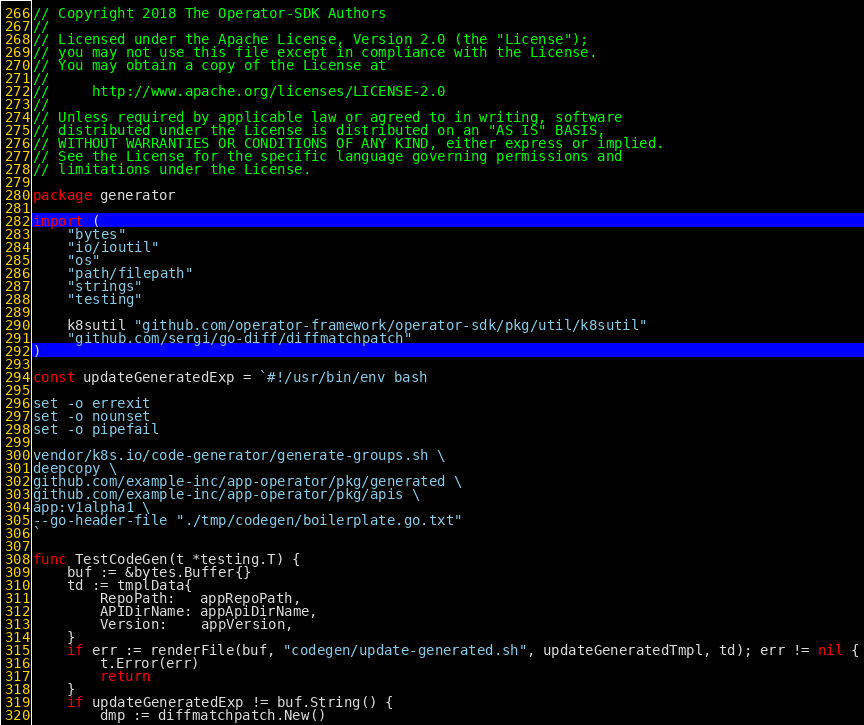<code> <loc_0><loc_0><loc_500><loc_500><_Go_>// Copyright 2018 The Operator-SDK Authors
//
// Licensed under the Apache License, Version 2.0 (the "License");
// you may not use this file except in compliance with the License.
// You may obtain a copy of the License at
//
//     http://www.apache.org/licenses/LICENSE-2.0
//
// Unless required by applicable law or agreed to in writing, software
// distributed under the License is distributed on an "AS IS" BASIS,
// WITHOUT WARRANTIES OR CONDITIONS OF ANY KIND, either express or implied.
// See the License for the specific language governing permissions and
// limitations under the License.

package generator

import (
	"bytes"
	"io/ioutil"
	"os"
	"path/filepath"
	"strings"
	"testing"

	k8sutil "github.com/operator-framework/operator-sdk/pkg/util/k8sutil"
	"github.com/sergi/go-diff/diffmatchpatch"
)

const updateGeneratedExp = `#!/usr/bin/env bash

set -o errexit
set -o nounset
set -o pipefail

vendor/k8s.io/code-generator/generate-groups.sh \
deepcopy \
github.com/example-inc/app-operator/pkg/generated \
github.com/example-inc/app-operator/pkg/apis \
app:v1alpha1 \
--go-header-file "./tmp/codegen/boilerplate.go.txt"
`

func TestCodeGen(t *testing.T) {
	buf := &bytes.Buffer{}
	td := tmplData{
		RepoPath:   appRepoPath,
		APIDirName: appApiDirName,
		Version:    appVersion,
	}
	if err := renderFile(buf, "codegen/update-generated.sh", updateGeneratedTmpl, td); err != nil {
		t.Error(err)
		return
	}
	if updateGeneratedExp != buf.String() {
		dmp := diffmatchpatch.New()</code> 